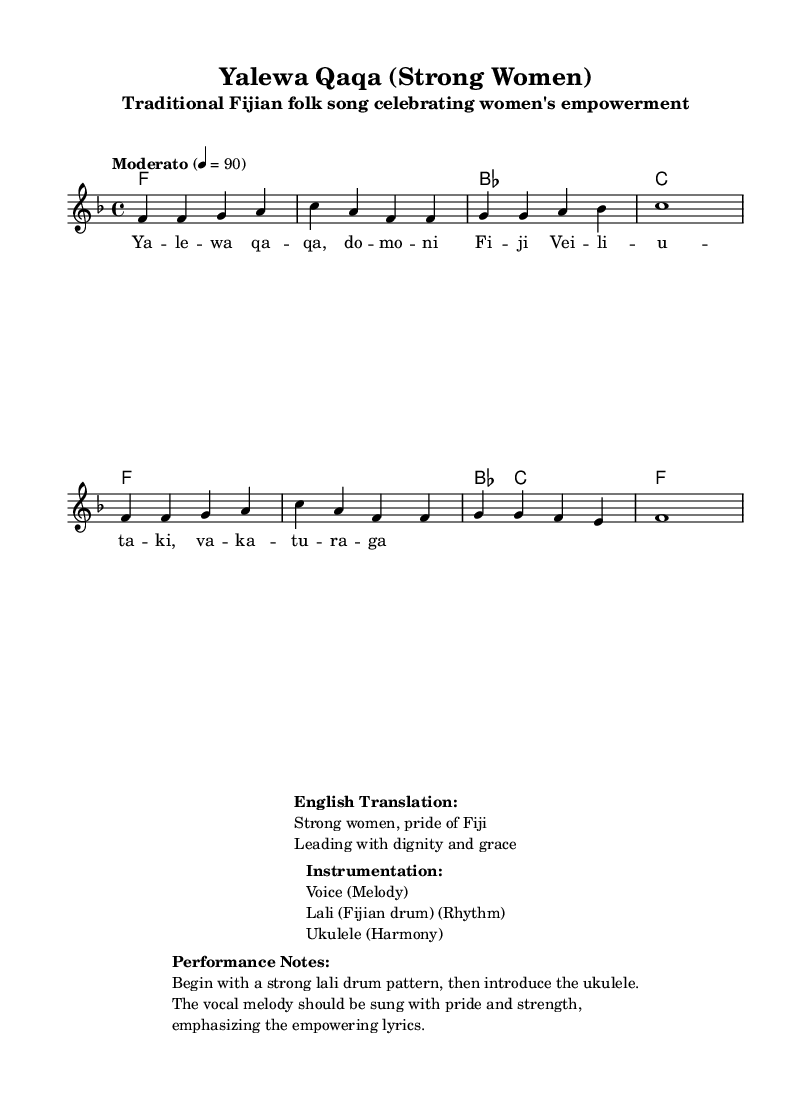What is the key signature of this music? The key signature is F major, which has one flat (B flat). This is indicated at the beginning of the music score.
Answer: F major What is the time signature of this music? The time signature is 4/4, which means there are four beats in each measure and a quarter note receives one beat. This is shown at the beginning of the score as well.
Answer: 4/4 What is the tempo marking of the piece? The tempo marking is "Moderato," which refers to a moderate speed, and it is indicated with a metronome marking of 90 beats per minute. This is found above the staff in the score.
Answer: Moderato How many measures are in the melody? The melody consists of 8 measures. This can be counted by looking at the bar lines that separate the measures in the melody section of the sheet music.
Answer: 8 What instrument accompanies the voice in this song? The instrument that accompanies the voice is the ukulele, as indicated in the instrumentation section of the sheet music.
Answer: Ukulele What is the main theme of the lyrics? The main theme of the lyrics is women's empowerment, as the song title "Yalewa Qaqa" translates to "Strong Women," celebrating Fiji's pride in women. This can be inferred from both the title and the translated lyrics provided.
Answer: Women's empowerment Describe how the piece should start according to the performance notes. The piece should begin with a strong lali drum pattern, which is noted in the performance notes section. After this, the ukulele is introduced before the melodic line begins.
Answer: Strong lali drum pattern 